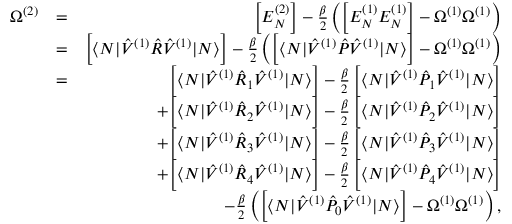<formula> <loc_0><loc_0><loc_500><loc_500>\begin{array} { r l r } { \Omega ^ { ( 2 ) } } & { = } & { \left [ E _ { N } ^ { ( 2 ) } \right ] - \frac { \beta } { 2 } \left ( \left [ E _ { N } ^ { ( 1 ) } E _ { N } ^ { ( 1 ) } \right ] - \Omega ^ { ( 1 ) } \Omega ^ { ( 1 ) } \right ) } \\ & { = } & { \left [ \langle N | \hat { V } ^ { ( 1 ) } \hat { R } \hat { V } ^ { ( 1 ) } | N \rangle \right ] - \frac { \beta } { 2 } \left ( \left [ \langle N | \hat { V } ^ { ( 1 ) } \hat { P } \hat { V } ^ { ( 1 ) } | N \rangle \right ] - \Omega ^ { ( 1 ) } \Omega ^ { ( 1 ) } \right ) } \\ & { = } & { \left [ \langle N | \hat { V } ^ { ( 1 ) } \hat { R } _ { 1 } \hat { V } ^ { ( 1 ) } | N \rangle \right ] - \frac { \beta } { 2 } \, \left [ \langle N | \hat { V } ^ { ( 1 ) } \hat { P } _ { 1 } \hat { V } ^ { ( 1 ) } | N \rangle \right ] } \\ & { + \left [ \langle N | \hat { V } ^ { ( 1 ) } \hat { R } _ { 2 } \hat { V } ^ { ( 1 ) } | N \rangle \right ] - \frac { \beta } { 2 } \, \left [ \langle N | \hat { V } ^ { ( 1 ) } \hat { P } _ { 2 } \hat { V } ^ { ( 1 ) } | N \rangle \right ] } \\ & { + \left [ \langle N | \hat { V } ^ { ( 1 ) } \hat { R } _ { 3 } \hat { V } ^ { ( 1 ) } | N \rangle \right ] - \frac { \beta } { 2 } \, \left [ \langle N | \hat { V } ^ { ( 1 ) } \hat { P } _ { 3 } \hat { V } ^ { ( 1 ) } | N \rangle \right ] } \\ & { + \left [ \langle N | \hat { V } ^ { ( 1 ) } \hat { R } _ { 4 } \hat { V } ^ { ( 1 ) } | N \rangle \right ] - \frac { \beta } { 2 } \, \left [ \langle N | \hat { V } ^ { ( 1 ) } \hat { P } _ { 4 } \hat { V } ^ { ( 1 ) } | N \rangle \right ] } \\ & { - \frac { \beta } { 2 } \left ( \left [ \langle N | \hat { V } ^ { ( 1 ) } \hat { P } _ { 0 } \hat { V } ^ { ( 1 ) } | N \rangle \right ] - \Omega ^ { ( 1 ) } \Omega ^ { ( 1 ) } \right ) , } \end{array}</formula> 